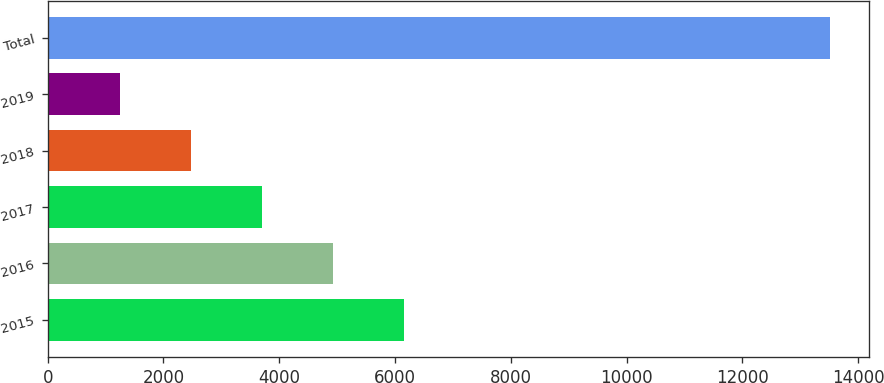Convert chart. <chart><loc_0><loc_0><loc_500><loc_500><bar_chart><fcel>2015<fcel>2016<fcel>2017<fcel>2018<fcel>2019<fcel>Total<nl><fcel>6154.6<fcel>4928.7<fcel>3702.8<fcel>2476.9<fcel>1251<fcel>13510<nl></chart> 